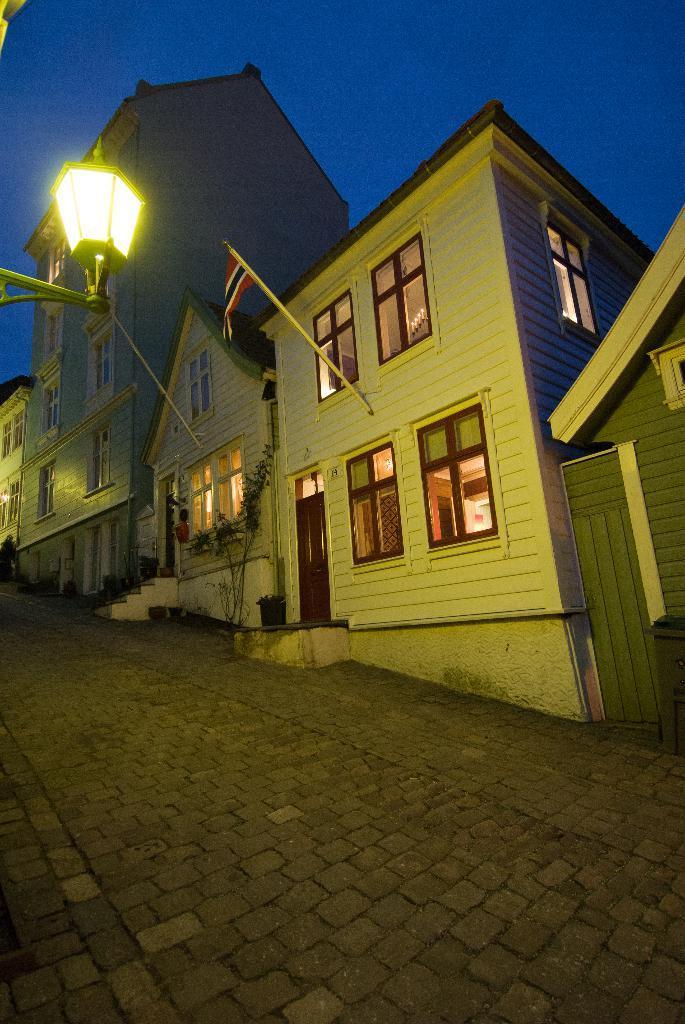How would you summarize this image in a sentence or two? These are the houses with windows and doors. This looks like a tree. I can see the flower pots. This is a flag hanging to the pole. I think this is a street lamp. 